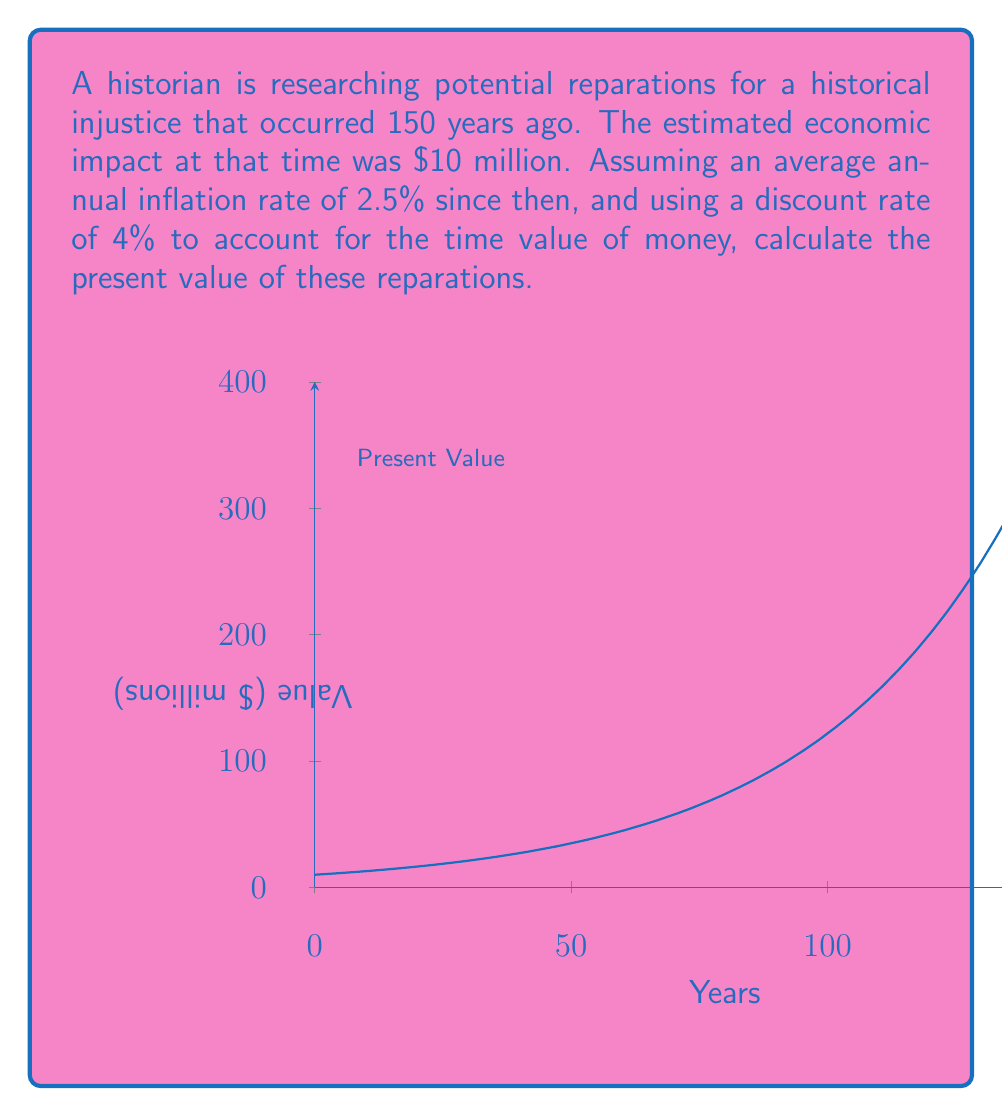Provide a solution to this math problem. To solve this problem, we'll follow these steps:

1) First, we need to calculate the future value of the $10 million after 150 years of inflation:
   
   $$FV = 10 \cdot (1 + 0.025)^{150}$$

   Using a calculator or computer, we get:
   $$FV \approx 383.66 \text{ million dollars}$$

2) Now, we need to discount this future value back to the present, using the 4% discount rate:

   $$PV = \frac{FV}{(1 + r)^n}$$

   Where:
   $PV$ = Present Value
   $FV$ = Future Value (383.66 million)
   $r$ = Discount rate (4% = 0.04)
   $n$ = Number of years (150)

3) Plugging in the values:

   $$PV = \frac{383.66}{(1 + 0.04)^{150}}$$

4) Using a calculator or computer to evaluate this expression:

   $$PV \approx 0.6917 \text{ million dollars}$$

Therefore, the present value of the reparations is approximately $691,700.
Answer: $691,700 